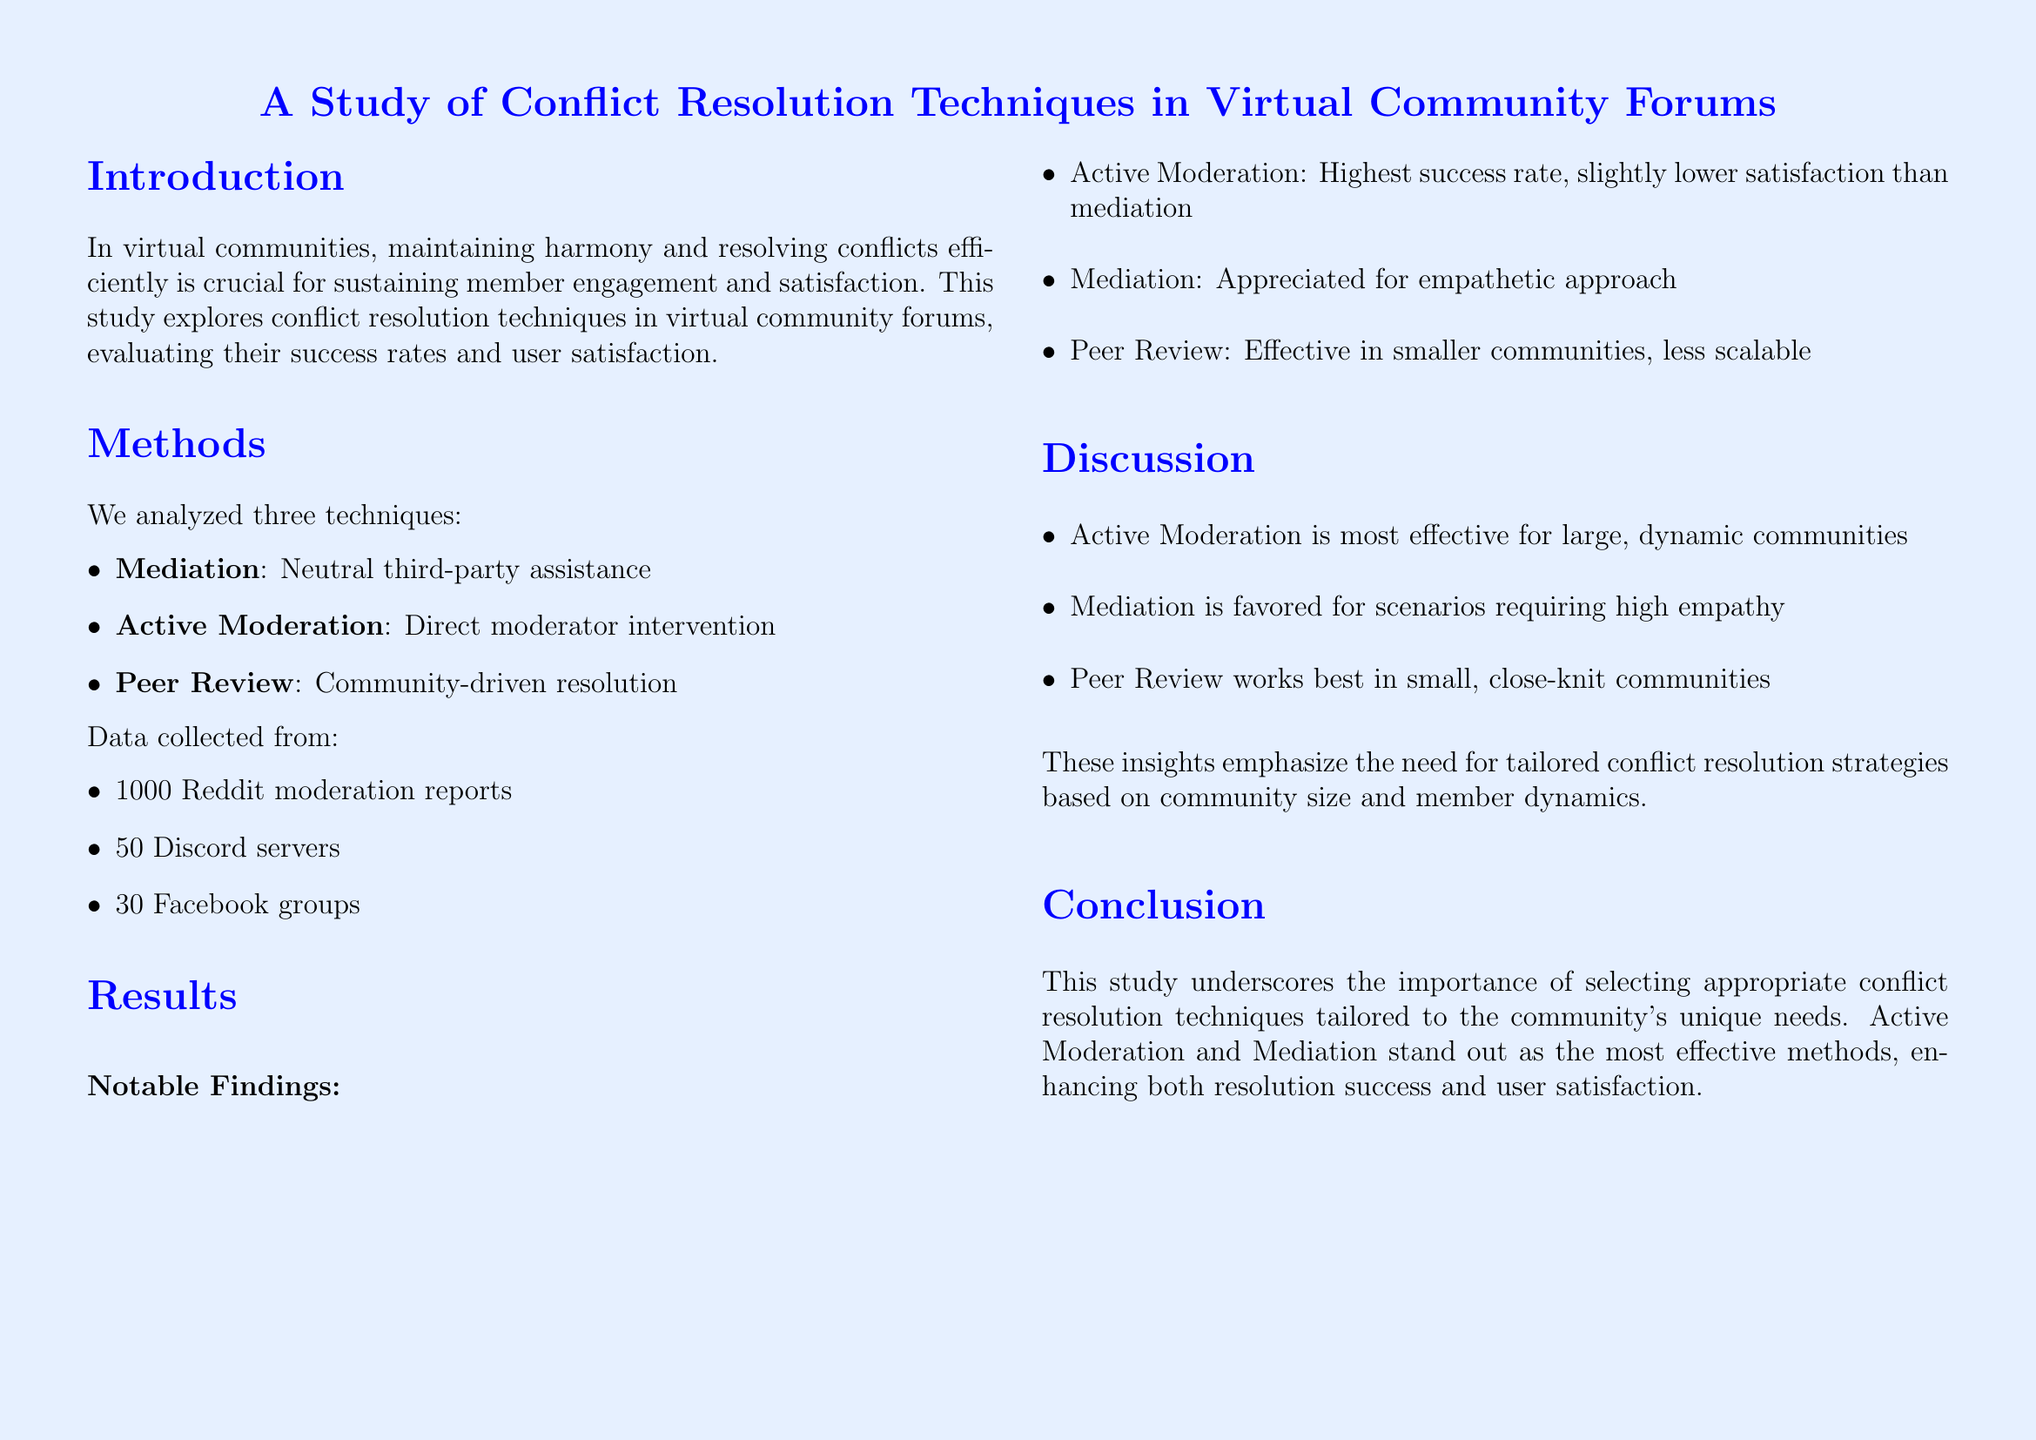What are the three conflict resolution techniques analyzed? The document lists the techniques as Mediation, Active Moderation, and Peer Review.
Answer: Mediation, Active Moderation, Peer Review What is the success rate of Active Moderation? The success rate for Active Moderation is specifically mentioned in the results section of the document.
Answer: 85% What is the user satisfaction rating for Mediation? The document provides a user satisfaction score for each technique, including Mediation.
Answer: 7.8/10 Which technique is noted for being appreciated for its empathetic approach? The notable findings indicate that Mediation is appreciated for empathy, highlighting user feedback.
Answer: Mediation Which conflict resolution technique is found to be most effective for large communities? The discussion section suggests that Active Moderation is the most effective method for large, dynamic communities.
Answer: Active Moderation What is the sample size of Discord servers analyzed in the study? The document specifies the number of Discord servers included in the data collection section.
Answer: 50 What technique shows the lowest success rate? By comparing the success rates in the results section, Peer Review has the lowest success rate.
Answer: Peer Review 